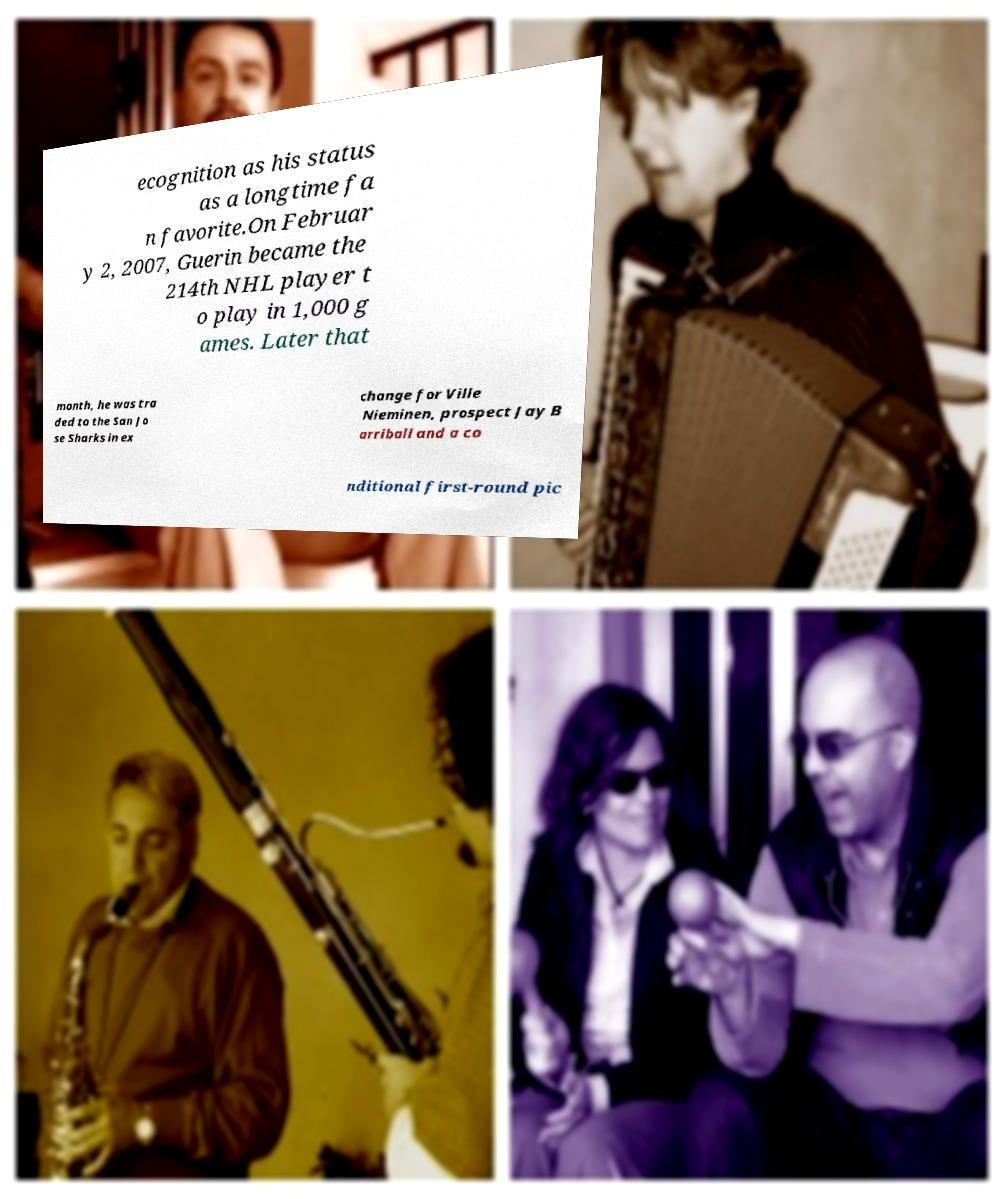Could you assist in decoding the text presented in this image and type it out clearly? ecognition as his status as a longtime fa n favorite.On Februar y 2, 2007, Guerin became the 214th NHL player t o play in 1,000 g ames. Later that month, he was tra ded to the San Jo se Sharks in ex change for Ville Nieminen, prospect Jay B arriball and a co nditional first-round pic 